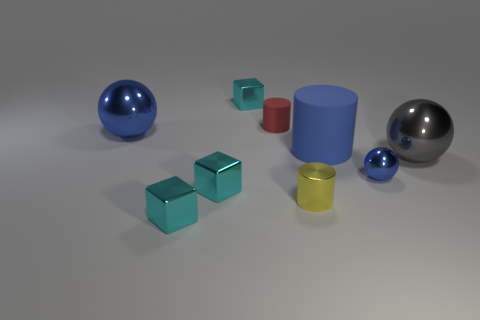Add 1 big matte balls. How many objects exist? 10 Subtract all spheres. How many objects are left? 6 Add 8 small blue objects. How many small blue objects exist? 9 Subtract 0 purple cylinders. How many objects are left? 9 Subtract all cylinders. Subtract all blue metallic things. How many objects are left? 4 Add 3 rubber things. How many rubber things are left? 5 